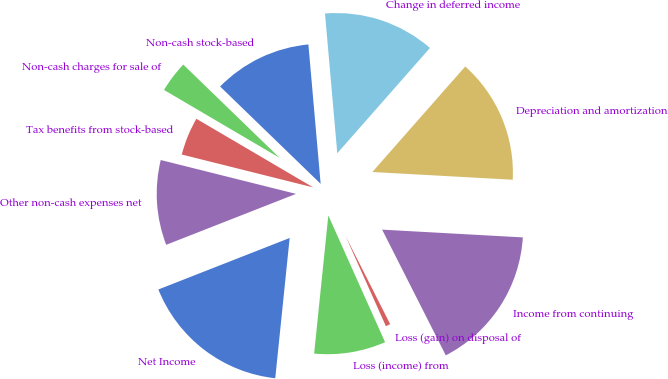Convert chart. <chart><loc_0><loc_0><loc_500><loc_500><pie_chart><fcel>Net Income<fcel>Loss (income) from<fcel>Loss (gain) on disposal of<fcel>Income from continuing<fcel>Depreciation and amortization<fcel>Change in deferred income<fcel>Non-cash stock-based<fcel>Non-cash charges for sale of<fcel>Tax benefits from stock-based<fcel>Other non-cash expenses net<nl><fcel>17.42%<fcel>8.33%<fcel>0.76%<fcel>16.66%<fcel>14.39%<fcel>12.88%<fcel>11.36%<fcel>3.79%<fcel>4.55%<fcel>9.85%<nl></chart> 